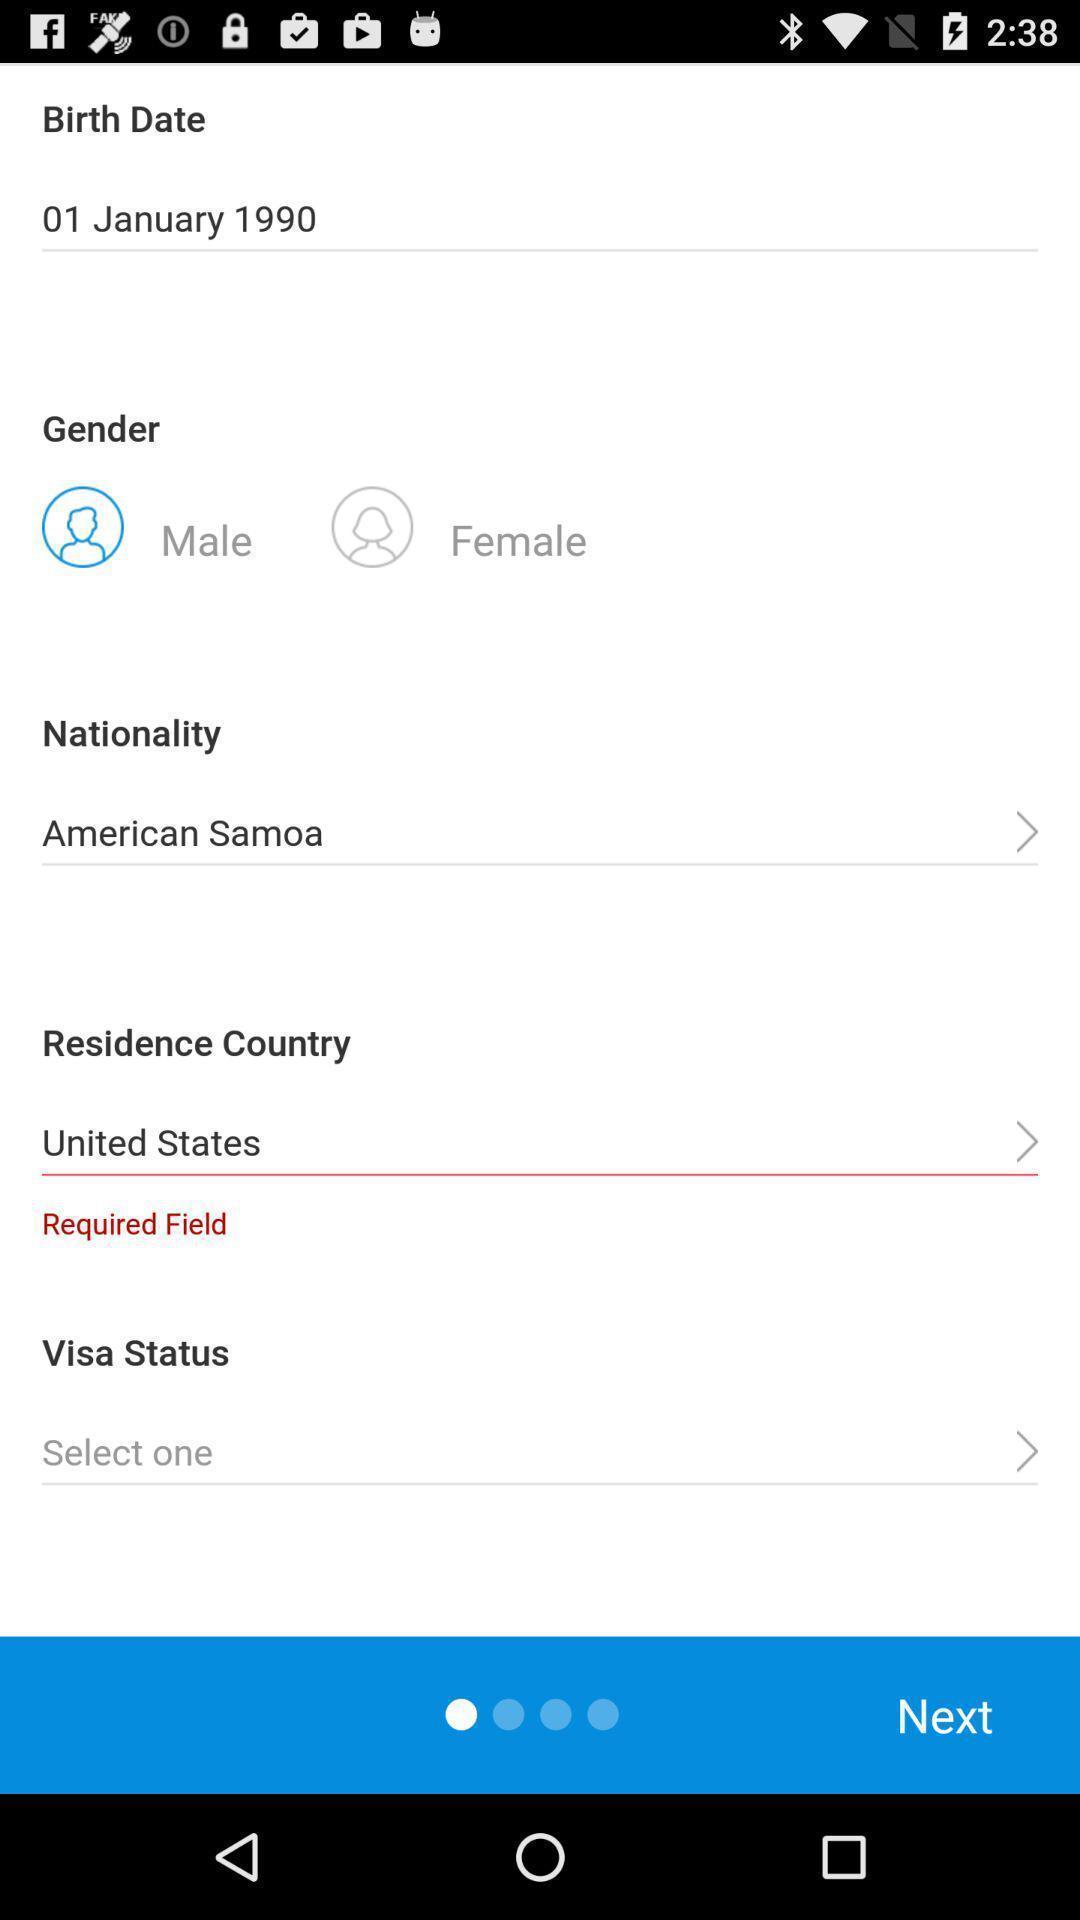Describe the visual elements of this screenshot. Registration page displayed. 